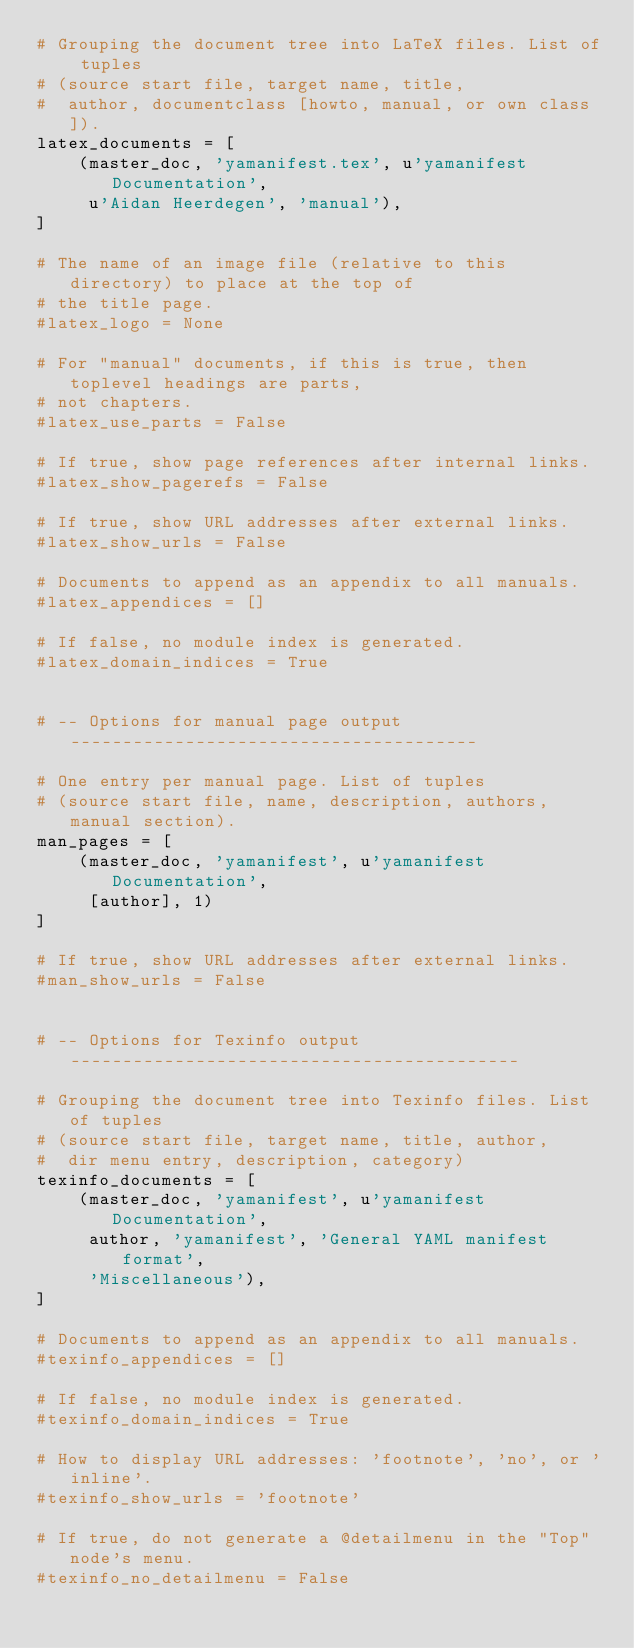<code> <loc_0><loc_0><loc_500><loc_500><_Python_># Grouping the document tree into LaTeX files. List of tuples
# (source start file, target name, title,
#  author, documentclass [howto, manual, or own class]).
latex_documents = [
    (master_doc, 'yamanifest.tex', u'yamanifest Documentation',
     u'Aidan Heerdegen', 'manual'),
]

# The name of an image file (relative to this directory) to place at the top of
# the title page.
#latex_logo = None

# For "manual" documents, if this is true, then toplevel headings are parts,
# not chapters.
#latex_use_parts = False

# If true, show page references after internal links.
#latex_show_pagerefs = False

# If true, show URL addresses after external links.
#latex_show_urls = False

# Documents to append as an appendix to all manuals.
#latex_appendices = []

# If false, no module index is generated.
#latex_domain_indices = True


# -- Options for manual page output ---------------------------------------

# One entry per manual page. List of tuples
# (source start file, name, description, authors, manual section).
man_pages = [
    (master_doc, 'yamanifest', u'yamanifest Documentation',
     [author], 1)
]

# If true, show URL addresses after external links.
#man_show_urls = False


# -- Options for Texinfo output -------------------------------------------

# Grouping the document tree into Texinfo files. List of tuples
# (source start file, target name, title, author,
#  dir menu entry, description, category)
texinfo_documents = [
    (master_doc, 'yamanifest', u'yamanifest Documentation',
     author, 'yamanifest', 'General YAML manifest format',
     'Miscellaneous'),
]

# Documents to append as an appendix to all manuals.
#texinfo_appendices = []

# If false, no module index is generated.
#texinfo_domain_indices = True

# How to display URL addresses: 'footnote', 'no', or 'inline'.
#texinfo_show_urls = 'footnote'

# If true, do not generate a @detailmenu in the "Top" node's menu.
#texinfo_no_detailmenu = False
</code> 